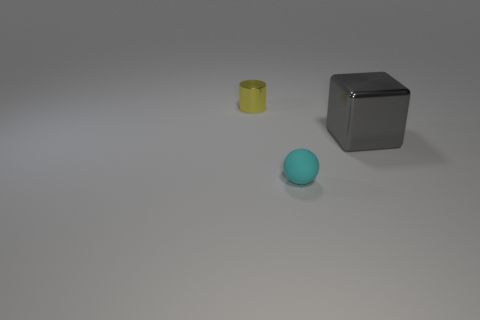There is a thing that is in front of the metal thing that is on the right side of the small metallic cylinder; what color is it?
Keep it short and to the point. Cyan. Are there fewer cubes that are behind the big cube than tiny matte spheres that are behind the tiny cyan sphere?
Make the answer very short. No. Is the shiny block the same size as the matte object?
Give a very brief answer. No. There is a thing that is both behind the cyan matte ball and on the left side of the cube; what is its shape?
Provide a short and direct response. Cylinder. What number of small yellow cylinders are the same material as the yellow object?
Offer a very short reply. 0. There is a object in front of the big metallic object; how many large blocks are on the right side of it?
Provide a short and direct response. 1. There is a tiny thing that is in front of the tiny thing behind the metal object on the right side of the tiny yellow cylinder; what shape is it?
Keep it short and to the point. Sphere. How many things are yellow spheres or cyan spheres?
Your answer should be compact. 1. There is a cylinder that is the same size as the sphere; what is its color?
Make the answer very short. Yellow. There is a large metal object; does it have the same shape as the tiny thing right of the small yellow metallic object?
Offer a terse response. No. 